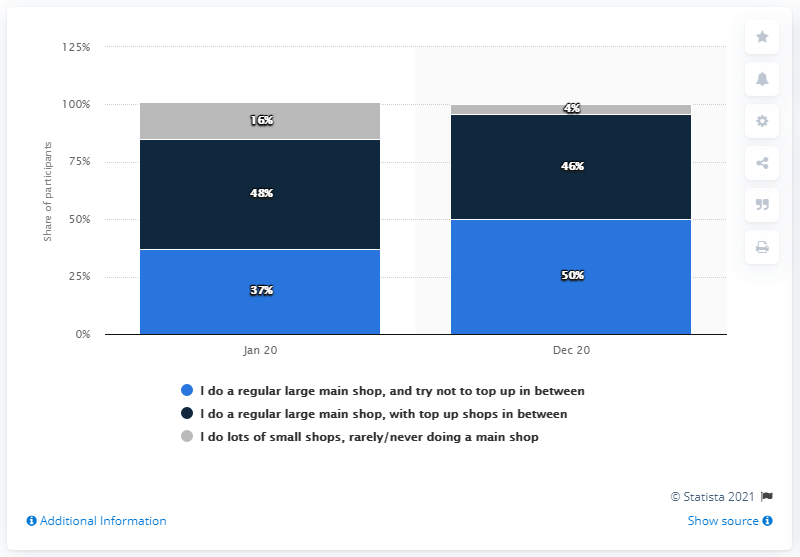Indicate a few pertinent items in this graphic. During the pandemic, the grocery shopping habit that underwent the most significant change was the practice of conducting a single, large main shop and avoiding top-up purchases in between. Previously, the speaker regularly performed a large main shop and refrained from making additional purchases. The maximum value of the gray bar is 16. 